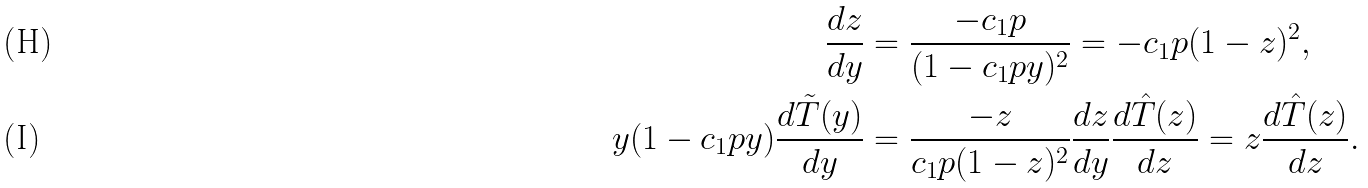Convert formula to latex. <formula><loc_0><loc_0><loc_500><loc_500>\frac { d z } { d y } & = \frac { - c _ { 1 } p } { ( 1 - c _ { 1 } p y ) ^ { 2 } } = - c _ { 1 } p ( 1 - z ) ^ { 2 } , \\ y ( 1 - c _ { 1 } p y ) \frac { d \tilde { T } ( y ) } { d y } & = \frac { - z } { c _ { 1 } p ( 1 - z ) ^ { 2 } } \frac { d z } { d y } \frac { d \hat { T } ( z ) } { d z } = z \frac { d \hat { T } ( z ) } { d z } .</formula> 